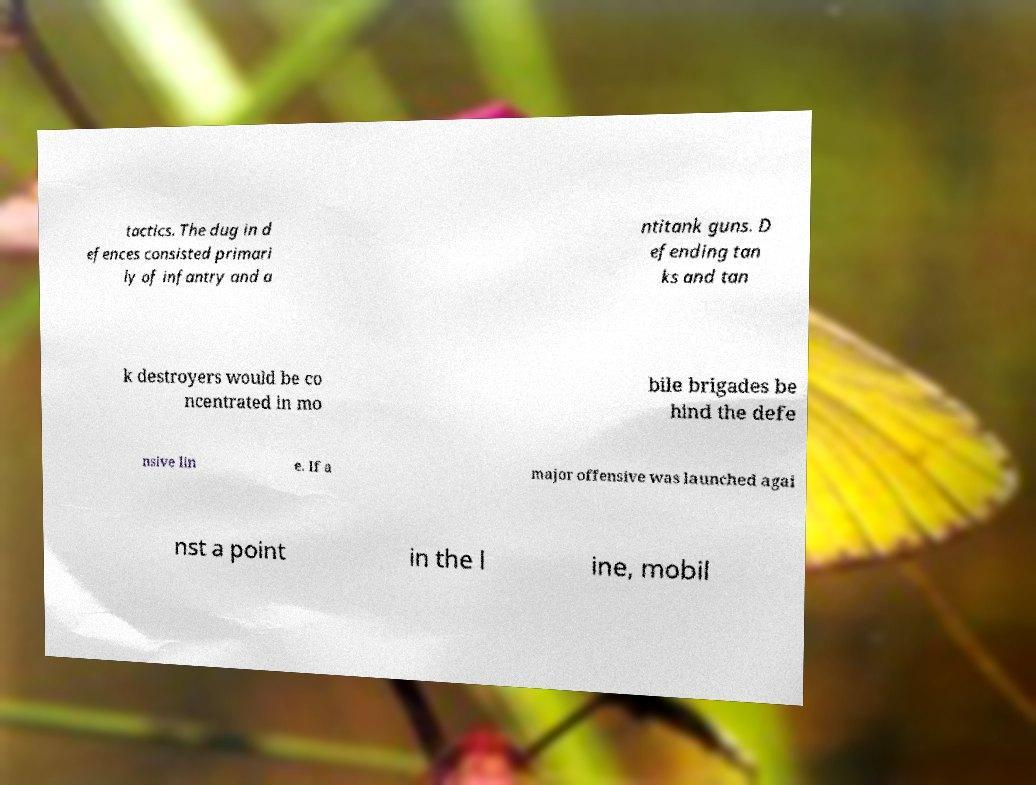Could you assist in decoding the text presented in this image and type it out clearly? tactics. The dug in d efences consisted primari ly of infantry and a ntitank guns. D efending tan ks and tan k destroyers would be co ncentrated in mo bile brigades be hind the defe nsive lin e. If a major offensive was launched agai nst a point in the l ine, mobil 